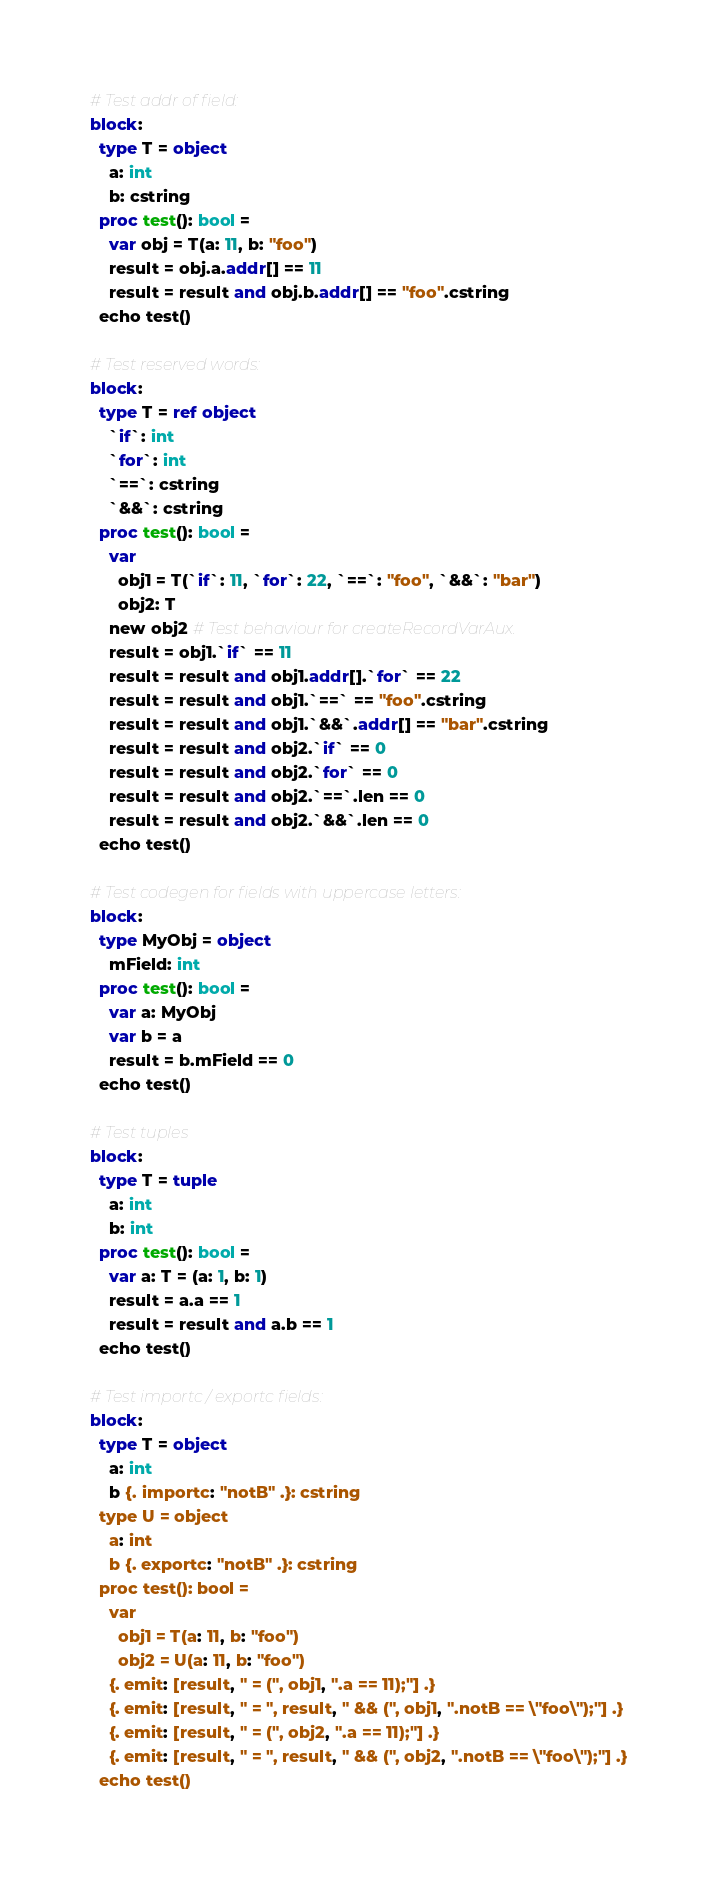Convert code to text. <code><loc_0><loc_0><loc_500><loc_500><_Nim_>
# Test addr of field:
block:
  type T = object
    a: int
    b: cstring
  proc test(): bool =
    var obj = T(a: 11, b: "foo")
    result = obj.a.addr[] == 11
    result = result and obj.b.addr[] == "foo".cstring
  echo test()

# Test reserved words:
block:
  type T = ref object
    `if`: int
    `for`: int
    `==`: cstring
    `&&`: cstring
  proc test(): bool =
    var
      obj1 = T(`if`: 11, `for`: 22, `==`: "foo", `&&`: "bar")
      obj2: T
    new obj2 # Test behaviour for createRecordVarAux.
    result = obj1.`if` == 11
    result = result and obj1.addr[].`for` == 22
    result = result and obj1.`==` == "foo".cstring
    result = result and obj1.`&&`.addr[] == "bar".cstring
    result = result and obj2.`if` == 0
    result = result and obj2.`for` == 0
    result = result and obj2.`==`.len == 0
    result = result and obj2.`&&`.len == 0
  echo test()

# Test codegen for fields with uppercase letters:
block:
  type MyObj = object
    mField: int
  proc test(): bool =
    var a: MyObj
    var b = a
    result = b.mField == 0
  echo test()

# Test tuples
block:
  type T = tuple
    a: int
    b: int
  proc test(): bool =
    var a: T = (a: 1, b: 1)
    result = a.a == 1
    result = result and a.b == 1
  echo test()

# Test importc / exportc fields:
block:
  type T = object
    a: int
    b {. importc: "notB" .}: cstring
  type U = object
    a: int
    b {. exportc: "notB" .}: cstring
  proc test(): bool =
    var
      obj1 = T(a: 11, b: "foo")
      obj2 = U(a: 11, b: "foo")
    {. emit: [result, " = (", obj1, ".a == 11);"] .}
    {. emit: [result, " = ", result, " && (", obj1, ".notB == \"foo\");"] .}
    {. emit: [result, " = (", obj2, ".a == 11);"] .}
    {. emit: [result, " = ", result, " && (", obj2, ".notB == \"foo\");"] .}
  echo test()
</code> 